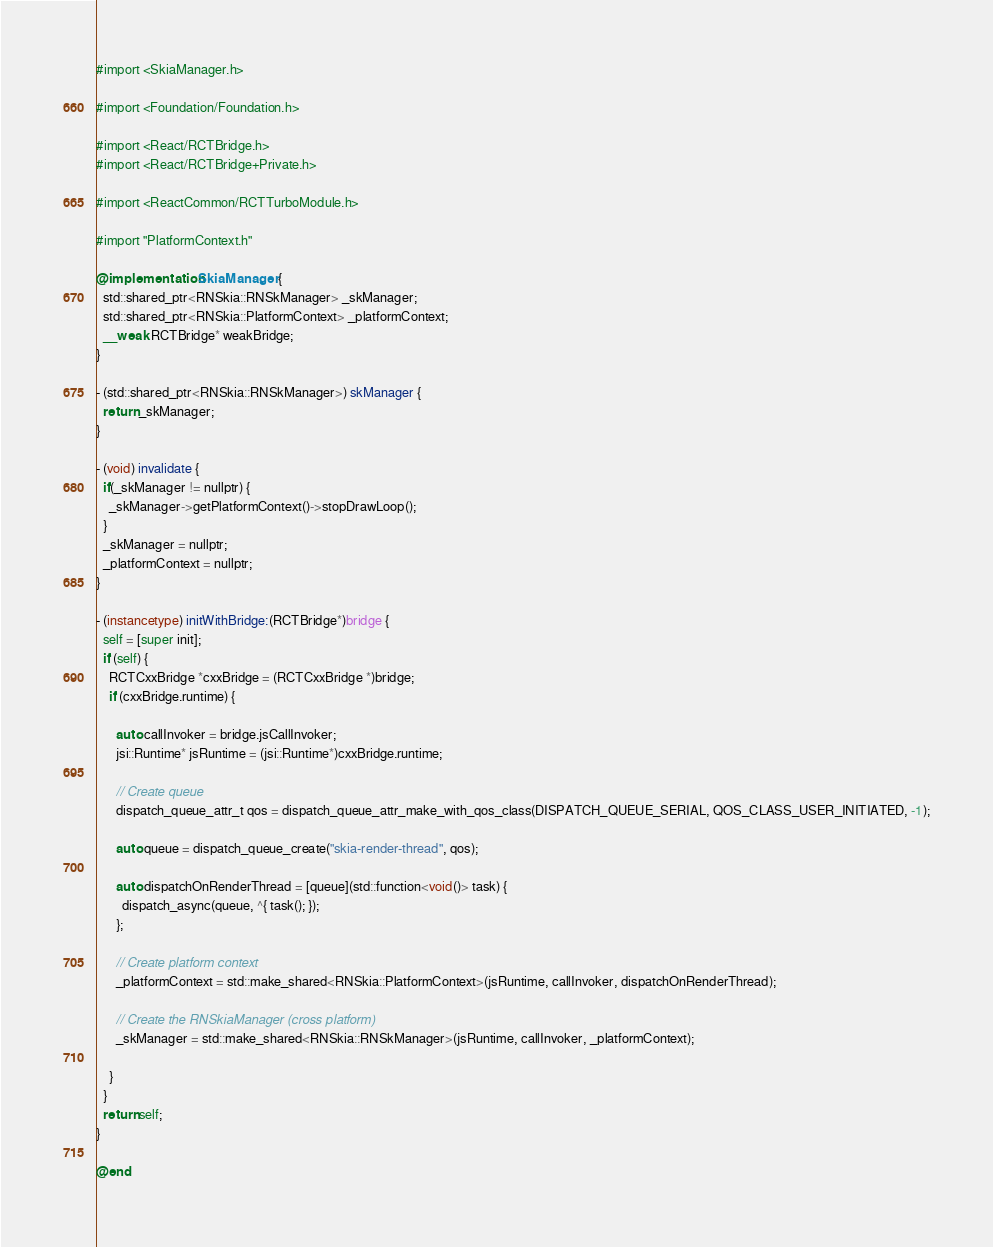Convert code to text. <code><loc_0><loc_0><loc_500><loc_500><_ObjectiveC_>#import <SkiaManager.h>

#import <Foundation/Foundation.h>

#import <React/RCTBridge.h>
#import <React/RCTBridge+Private.h>

#import <ReactCommon/RCTTurboModule.h>

#import "PlatformContext.h"

@implementation SkiaManager {
  std::shared_ptr<RNSkia::RNSkManager> _skManager;
  std::shared_ptr<RNSkia::PlatformContext> _platformContext;
  __weak RCTBridge* weakBridge;
}

- (std::shared_ptr<RNSkia::RNSkManager>) skManager {
  return _skManager;
}

- (void) invalidate {
  if(_skManager != nullptr) {
    _skManager->getPlatformContext()->stopDrawLoop();
  }
  _skManager = nullptr;
  _platformContext = nullptr;    
}

- (instancetype) initWithBridge:(RCTBridge*)bridge {
  self = [super init];
  if (self) {
    RCTCxxBridge *cxxBridge = (RCTCxxBridge *)bridge;
    if (cxxBridge.runtime) {
      
      auto callInvoker = bridge.jsCallInvoker;
      jsi::Runtime* jsRuntime = (jsi::Runtime*)cxxBridge.runtime;
      
      // Create queue
      dispatch_queue_attr_t qos = dispatch_queue_attr_make_with_qos_class(DISPATCH_QUEUE_SERIAL, QOS_CLASS_USER_INITIATED, -1);
            
      auto queue = dispatch_queue_create("skia-render-thread", qos);
      
      auto dispatchOnRenderThread = [queue](std::function<void()> task) {
        dispatch_async(queue, ^{ task(); });
      };
      
      // Create platform context
      _platformContext = std::make_shared<RNSkia::PlatformContext>(jsRuntime, callInvoker, dispatchOnRenderThread);
            
      // Create the RNSkiaManager (cross platform)
      _skManager = std::make_shared<RNSkia::RNSkManager>(jsRuntime, callInvoker, _platformContext);
          
    }
  }
  return self;
}

@end
</code> 